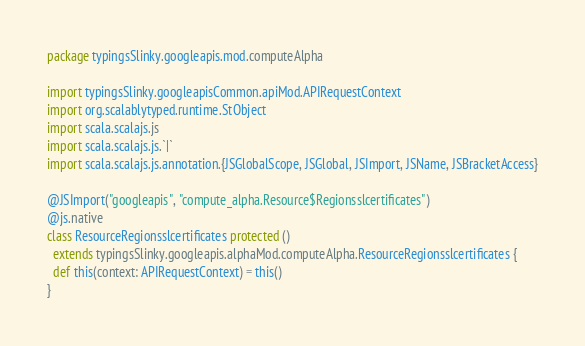Convert code to text. <code><loc_0><loc_0><loc_500><loc_500><_Scala_>package typingsSlinky.googleapis.mod.computeAlpha

import typingsSlinky.googleapisCommon.apiMod.APIRequestContext
import org.scalablytyped.runtime.StObject
import scala.scalajs.js
import scala.scalajs.js.`|`
import scala.scalajs.js.annotation.{JSGlobalScope, JSGlobal, JSImport, JSName, JSBracketAccess}

@JSImport("googleapis", "compute_alpha.Resource$Regionsslcertificates")
@js.native
class ResourceRegionsslcertificates protected ()
  extends typingsSlinky.googleapis.alphaMod.computeAlpha.ResourceRegionsslcertificates {
  def this(context: APIRequestContext) = this()
}
</code> 